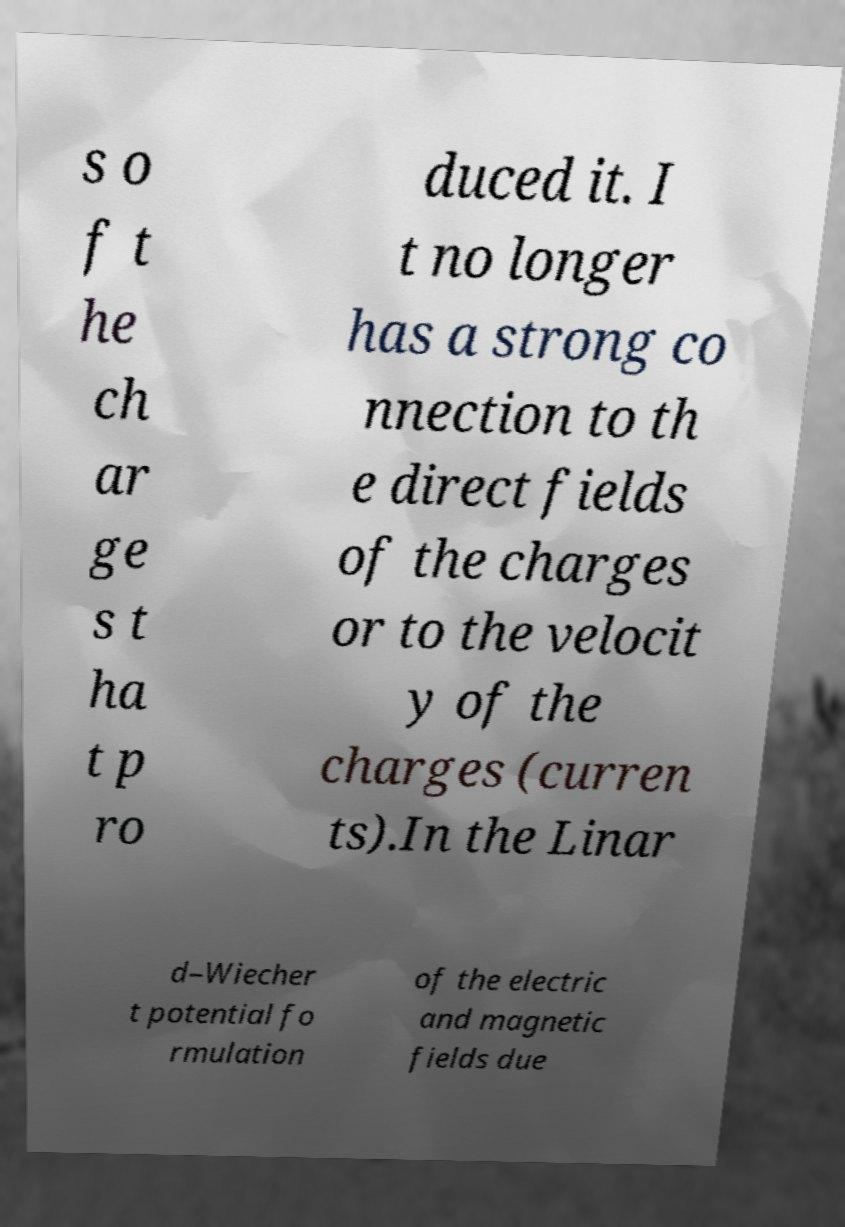There's text embedded in this image that I need extracted. Can you transcribe it verbatim? s o f t he ch ar ge s t ha t p ro duced it. I t no longer has a strong co nnection to th e direct fields of the charges or to the velocit y of the charges (curren ts).In the Linar d–Wiecher t potential fo rmulation of the electric and magnetic fields due 